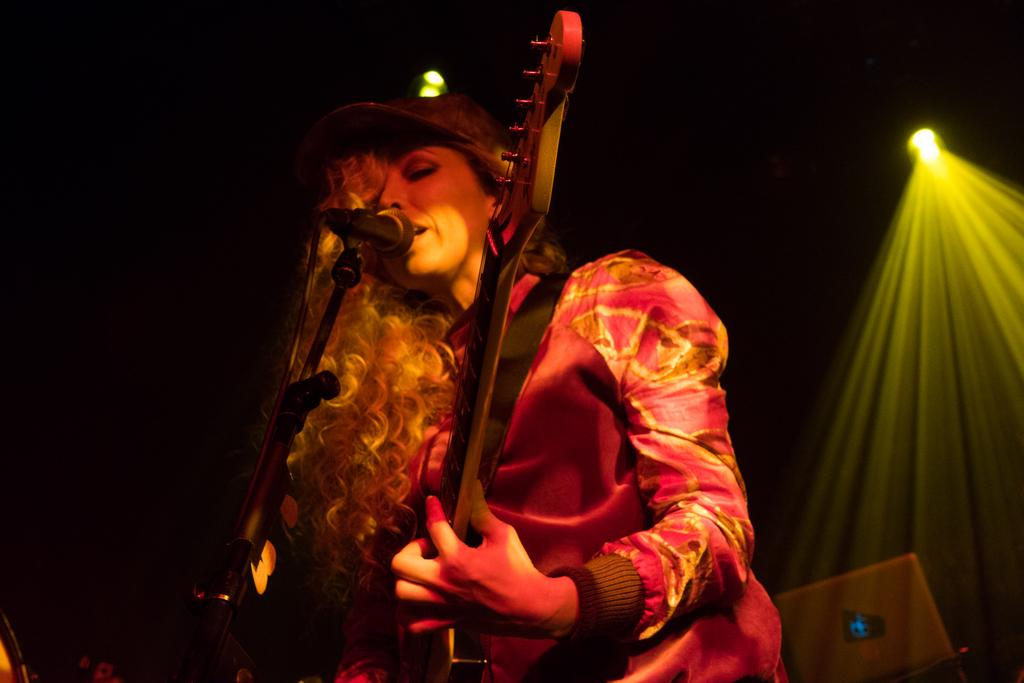What is the lady in the image doing? The lady is standing in the center of the image and holding a guitar. What object is placed in front of the lady? There is a microphone placed on a stand before the lady. What can be seen in the background of the image? There are lights and a laptop visible in the background. What question is the lady asking the audience in the image? There is no indication in the image that the lady is asking a question or interacting with an audience. 